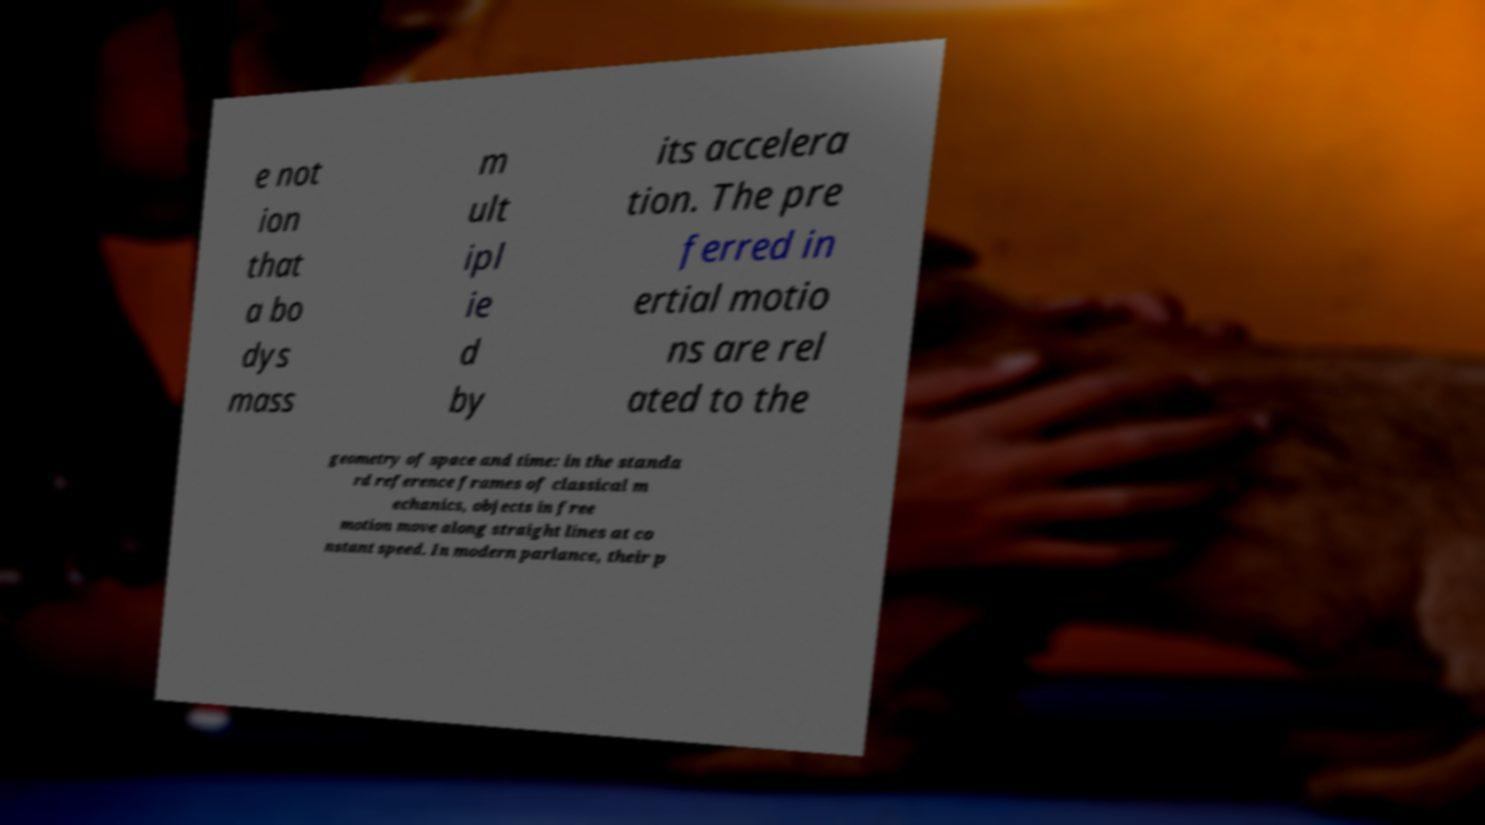Could you extract and type out the text from this image? e not ion that a bo dys mass m ult ipl ie d by its accelera tion. The pre ferred in ertial motio ns are rel ated to the geometry of space and time: in the standa rd reference frames of classical m echanics, objects in free motion move along straight lines at co nstant speed. In modern parlance, their p 